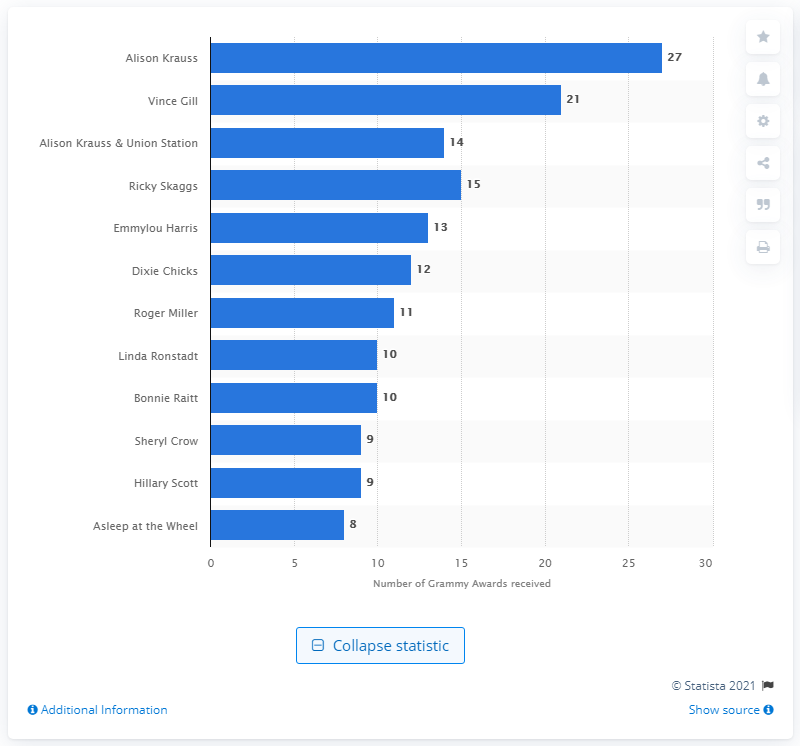Specify some key components in this picture. Alison Krauss has won a total of 27 Grammy awards. Alison Krauss, a country artist, has won the most Grammy Awards of all time. 